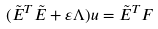<formula> <loc_0><loc_0><loc_500><loc_500>( \tilde { E } ^ { T } \tilde { E } + \varepsilon \Lambda ) u = \tilde { E } ^ { T } F</formula> 